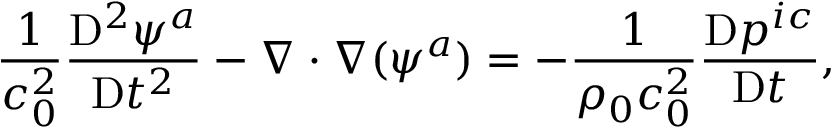Convert formula to latex. <formula><loc_0><loc_0><loc_500><loc_500>\frac { 1 } { c _ { 0 } ^ { 2 } } \frac { D ^ { 2 } \psi ^ { a } } { D t ^ { 2 } } - \nabla \cdot \nabla ( \psi ^ { a } ) = - \frac { 1 } { \rho _ { 0 } c _ { 0 } ^ { 2 } } \frac { D p ^ { i c } } { D t } ,</formula> 